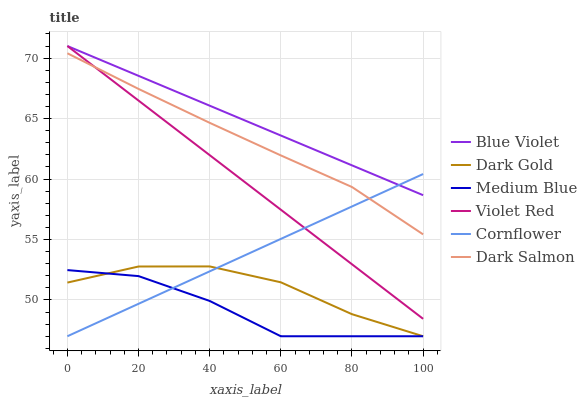Does Medium Blue have the minimum area under the curve?
Answer yes or no. Yes. Does Blue Violet have the maximum area under the curve?
Answer yes or no. Yes. Does Violet Red have the minimum area under the curve?
Answer yes or no. No. Does Violet Red have the maximum area under the curve?
Answer yes or no. No. Is Blue Violet the smoothest?
Answer yes or no. Yes. Is Medium Blue the roughest?
Answer yes or no. Yes. Is Violet Red the smoothest?
Answer yes or no. No. Is Violet Red the roughest?
Answer yes or no. No. Does Cornflower have the lowest value?
Answer yes or no. Yes. Does Violet Red have the lowest value?
Answer yes or no. No. Does Blue Violet have the highest value?
Answer yes or no. Yes. Does Dark Gold have the highest value?
Answer yes or no. No. Is Medium Blue less than Blue Violet?
Answer yes or no. Yes. Is Dark Salmon greater than Medium Blue?
Answer yes or no. Yes. Does Cornflower intersect Blue Violet?
Answer yes or no. Yes. Is Cornflower less than Blue Violet?
Answer yes or no. No. Is Cornflower greater than Blue Violet?
Answer yes or no. No. Does Medium Blue intersect Blue Violet?
Answer yes or no. No. 